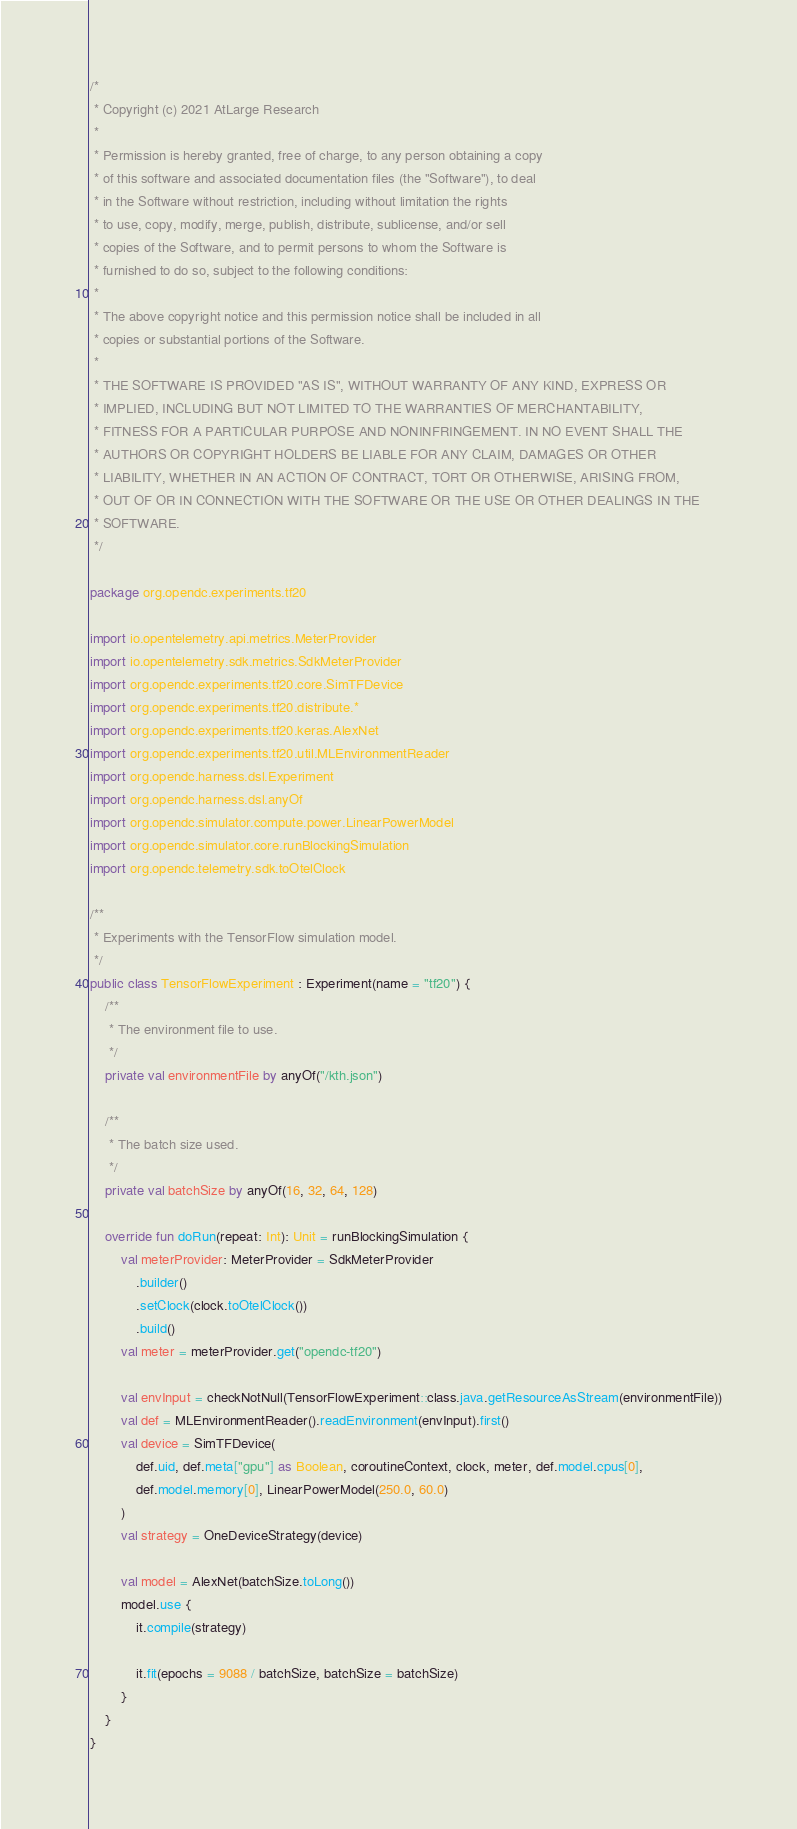Convert code to text. <code><loc_0><loc_0><loc_500><loc_500><_Kotlin_>/*
 * Copyright (c) 2021 AtLarge Research
 *
 * Permission is hereby granted, free of charge, to any person obtaining a copy
 * of this software and associated documentation files (the "Software"), to deal
 * in the Software without restriction, including without limitation the rights
 * to use, copy, modify, merge, publish, distribute, sublicense, and/or sell
 * copies of the Software, and to permit persons to whom the Software is
 * furnished to do so, subject to the following conditions:
 *
 * The above copyright notice and this permission notice shall be included in all
 * copies or substantial portions of the Software.
 *
 * THE SOFTWARE IS PROVIDED "AS IS", WITHOUT WARRANTY OF ANY KIND, EXPRESS OR
 * IMPLIED, INCLUDING BUT NOT LIMITED TO THE WARRANTIES OF MERCHANTABILITY,
 * FITNESS FOR A PARTICULAR PURPOSE AND NONINFRINGEMENT. IN NO EVENT SHALL THE
 * AUTHORS OR COPYRIGHT HOLDERS BE LIABLE FOR ANY CLAIM, DAMAGES OR OTHER
 * LIABILITY, WHETHER IN AN ACTION OF CONTRACT, TORT OR OTHERWISE, ARISING FROM,
 * OUT OF OR IN CONNECTION WITH THE SOFTWARE OR THE USE OR OTHER DEALINGS IN THE
 * SOFTWARE.
 */

package org.opendc.experiments.tf20

import io.opentelemetry.api.metrics.MeterProvider
import io.opentelemetry.sdk.metrics.SdkMeterProvider
import org.opendc.experiments.tf20.core.SimTFDevice
import org.opendc.experiments.tf20.distribute.*
import org.opendc.experiments.tf20.keras.AlexNet
import org.opendc.experiments.tf20.util.MLEnvironmentReader
import org.opendc.harness.dsl.Experiment
import org.opendc.harness.dsl.anyOf
import org.opendc.simulator.compute.power.LinearPowerModel
import org.opendc.simulator.core.runBlockingSimulation
import org.opendc.telemetry.sdk.toOtelClock

/**
 * Experiments with the TensorFlow simulation model.
 */
public class TensorFlowExperiment : Experiment(name = "tf20") {
    /**
     * The environment file to use.
     */
    private val environmentFile by anyOf("/kth.json")

    /**
     * The batch size used.
     */
    private val batchSize by anyOf(16, 32, 64, 128)

    override fun doRun(repeat: Int): Unit = runBlockingSimulation {
        val meterProvider: MeterProvider = SdkMeterProvider
            .builder()
            .setClock(clock.toOtelClock())
            .build()
        val meter = meterProvider.get("opendc-tf20")

        val envInput = checkNotNull(TensorFlowExperiment::class.java.getResourceAsStream(environmentFile))
        val def = MLEnvironmentReader().readEnvironment(envInput).first()
        val device = SimTFDevice(
            def.uid, def.meta["gpu"] as Boolean, coroutineContext, clock, meter, def.model.cpus[0],
            def.model.memory[0], LinearPowerModel(250.0, 60.0)
        )
        val strategy = OneDeviceStrategy(device)

        val model = AlexNet(batchSize.toLong())
        model.use {
            it.compile(strategy)

            it.fit(epochs = 9088 / batchSize, batchSize = batchSize)
        }
    }
}
</code> 